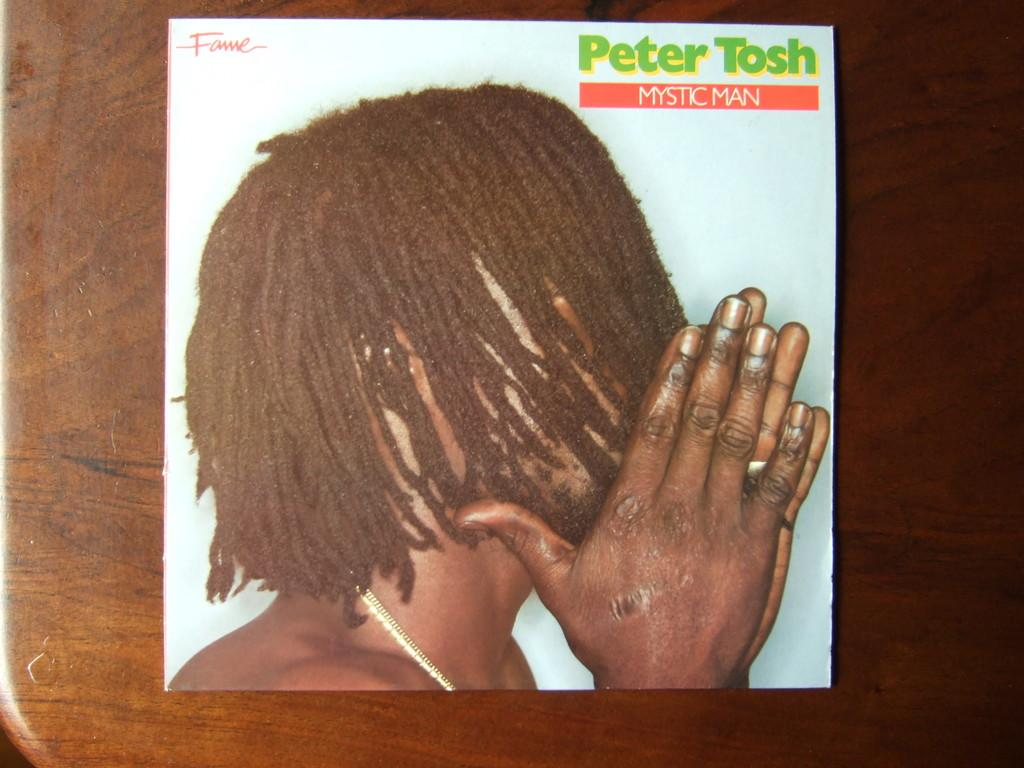What is the main subject of the image? The main subject of the image is a cover page. Where is the cover page located? The cover page is on a table. What type of ornament is hanging from the cover page in the image? There is no ornament hanging from the cover page in the image. Can you tell me what the grandmother is doing in the image? There is no grandmother present in the image. Is the doll interacting with the cover page in the image? There is no doll present in the image. 